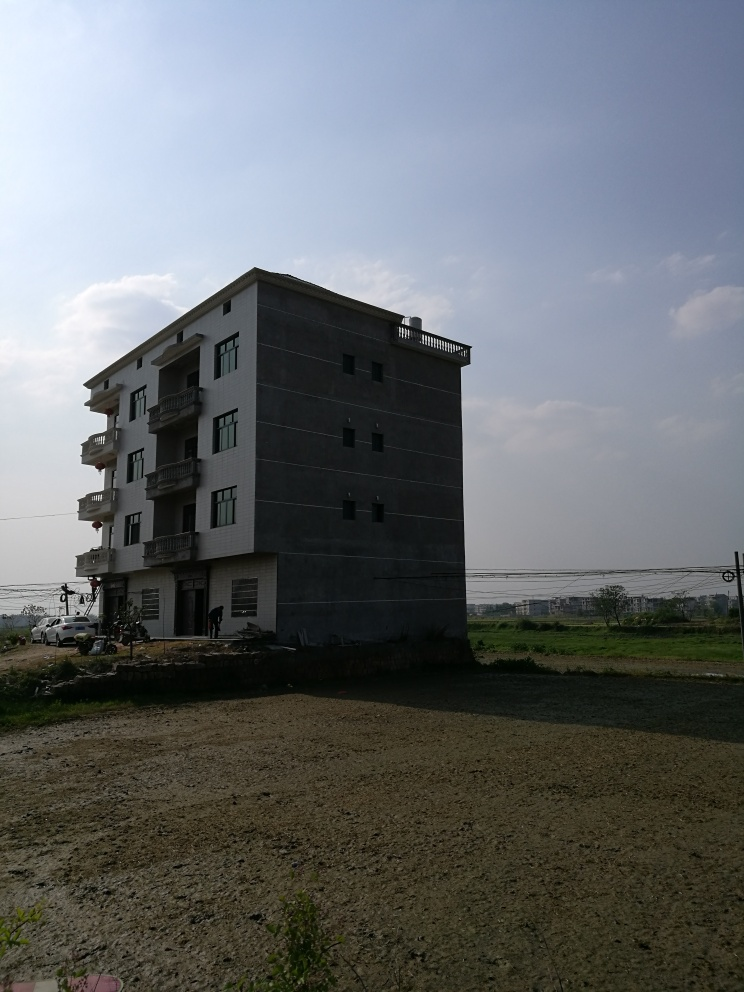Does the house lack texture details? The house in the image does exhibit a smooth facade without intricate textural details. The walls appear to be uniformly coated, perhaps with paint or a plain render, which does not provide much in the way of texture variation or ornamentation. 